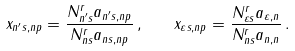<formula> <loc_0><loc_0><loc_500><loc_500>x _ { n ^ { \prime } s , n p } = \frac { N ^ { r } _ { n ^ { \prime } s } a _ { n ^ { \prime } s , n p } } { N ^ { r } _ { n s } a _ { n s , n p } } \, , \quad x _ { \varepsilon s , n p } = \frac { N ^ { r } _ { \varepsilon s } a _ { \varepsilon , n } } { N ^ { r } _ { n s } a _ { n , n } } \, .</formula> 